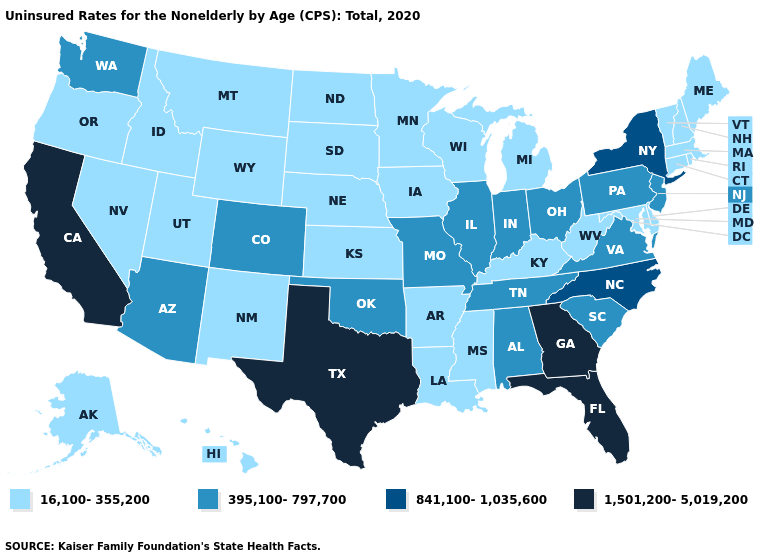What is the highest value in the South ?
Be succinct. 1,501,200-5,019,200. Does Washington have a higher value than Arizona?
Write a very short answer. No. Which states have the highest value in the USA?
Quick response, please. California, Florida, Georgia, Texas. What is the value of Utah?
Give a very brief answer. 16,100-355,200. Does Ohio have a higher value than Pennsylvania?
Quick response, please. No. What is the lowest value in states that border South Carolina?
Give a very brief answer. 841,100-1,035,600. How many symbols are there in the legend?
Write a very short answer. 4. Does New Mexico have a lower value than Minnesota?
Be succinct. No. Does Texas have the highest value in the USA?
Answer briefly. Yes. What is the lowest value in states that border Arkansas?
Keep it brief. 16,100-355,200. What is the lowest value in states that border Arkansas?
Write a very short answer. 16,100-355,200. Name the states that have a value in the range 1,501,200-5,019,200?
Keep it brief. California, Florida, Georgia, Texas. Among the states that border Massachusetts , which have the highest value?
Be succinct. New York. What is the value of Connecticut?
Short answer required. 16,100-355,200. Among the states that border Tennessee , does Georgia have the highest value?
Answer briefly. Yes. 